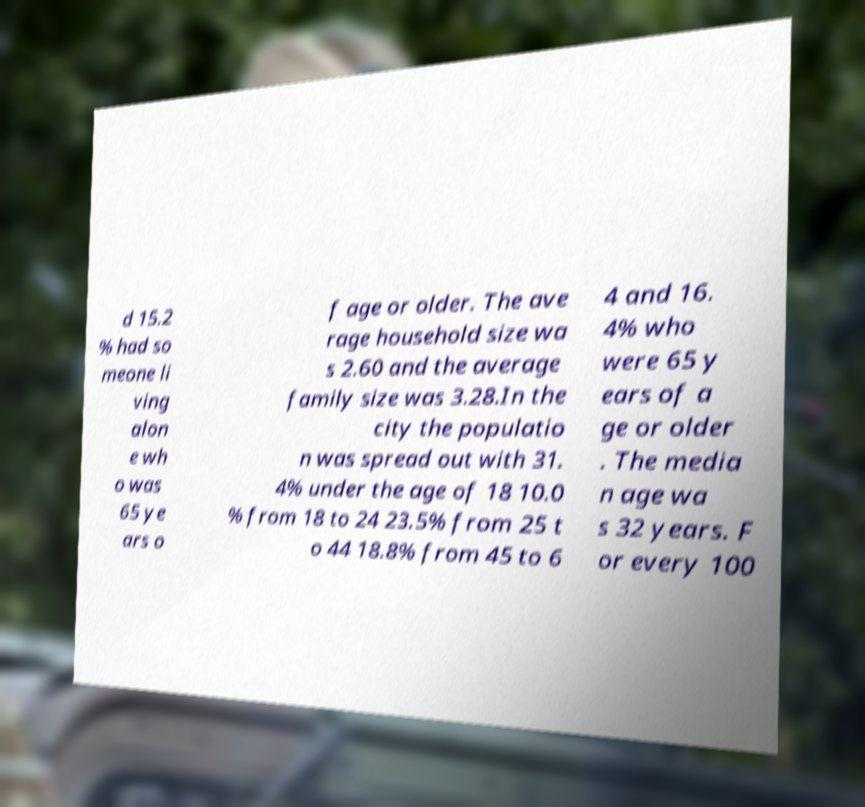Can you accurately transcribe the text from the provided image for me? d 15.2 % had so meone li ving alon e wh o was 65 ye ars o f age or older. The ave rage household size wa s 2.60 and the average family size was 3.28.In the city the populatio n was spread out with 31. 4% under the age of 18 10.0 % from 18 to 24 23.5% from 25 t o 44 18.8% from 45 to 6 4 and 16. 4% who were 65 y ears of a ge or older . The media n age wa s 32 years. F or every 100 